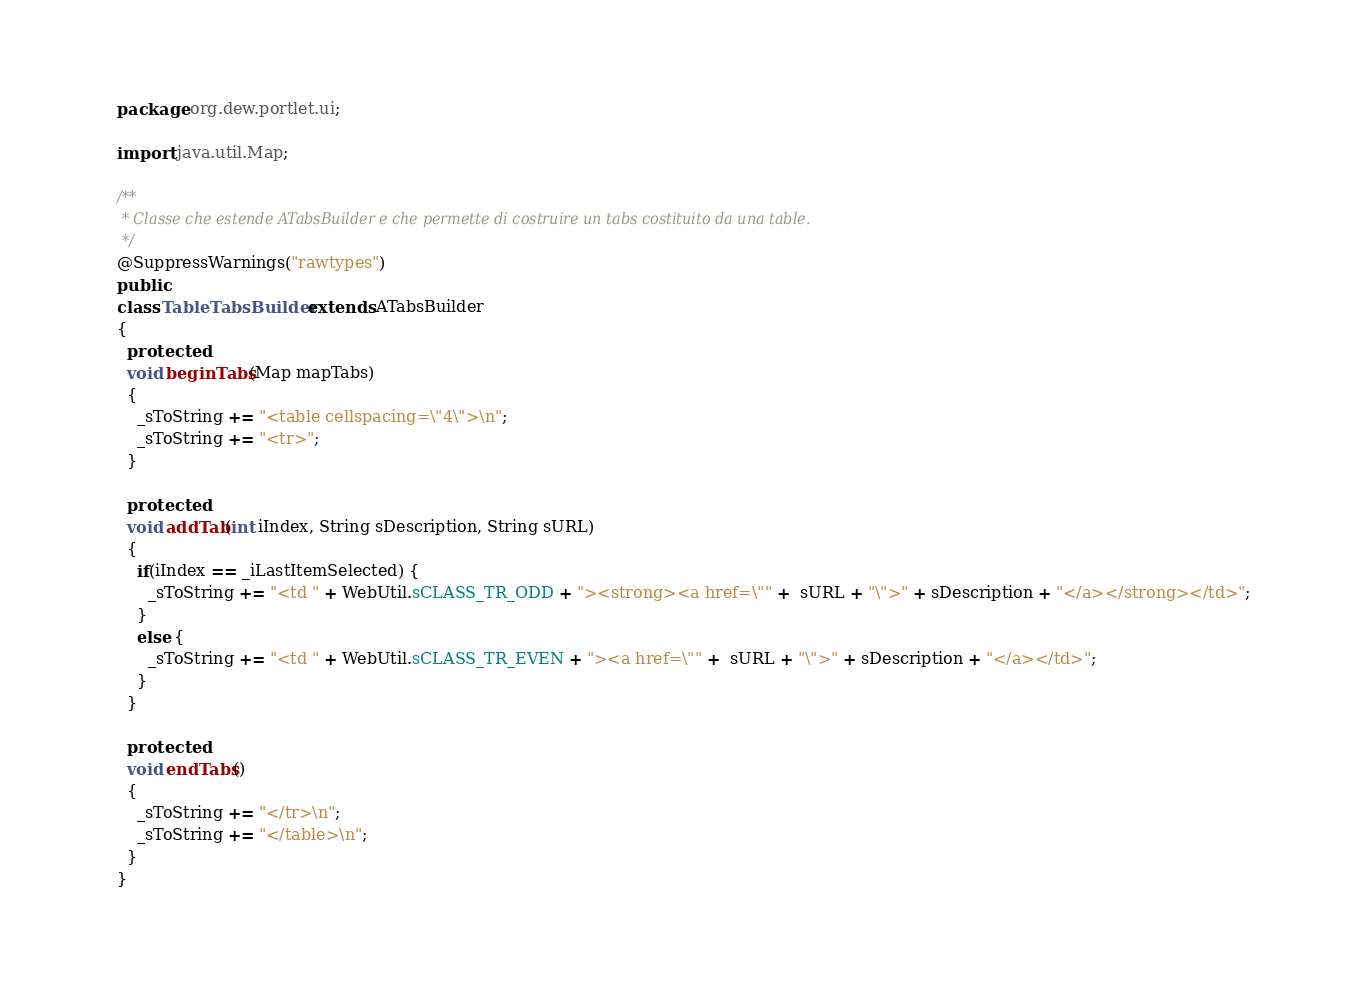<code> <loc_0><loc_0><loc_500><loc_500><_Java_>package org.dew.portlet.ui;

import java.util.Map;

/**
 * Classe che estende ATabsBuilder e che permette di costruire un tabs costituito da una table.
 */
@SuppressWarnings("rawtypes")
public 
class TableTabsBuilder extends ATabsBuilder 
{
  protected 
  void beginTabs(Map mapTabs) 
  {
    _sToString += "<table cellspacing=\"4\">\n";
    _sToString += "<tr>";
  }
  
  protected 
  void addTab(int iIndex, String sDescription, String sURL) 
  {
    if(iIndex == _iLastItemSelected) {
      _sToString += "<td " + WebUtil.sCLASS_TR_ODD + "><strong><a href=\"" +  sURL + "\">" + sDescription + "</a></strong></td>";
    }
    else {
      _sToString += "<td " + WebUtil.sCLASS_TR_EVEN + "><a href=\"" +  sURL + "\">" + sDescription + "</a></td>";
    }
  }
  
  protected 
  void endTabs() 
  {
    _sToString += "</tr>\n";
    _sToString += "</table>\n";
  }
}
</code> 